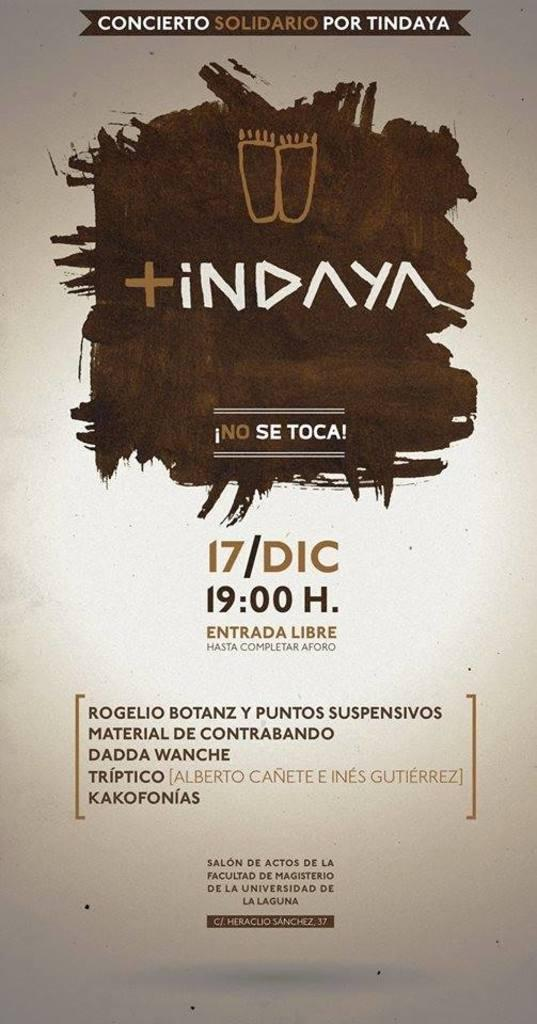<image>
Relay a brief, clear account of the picture shown. According to its poster, an advertised event takes place at 19:00 H. 